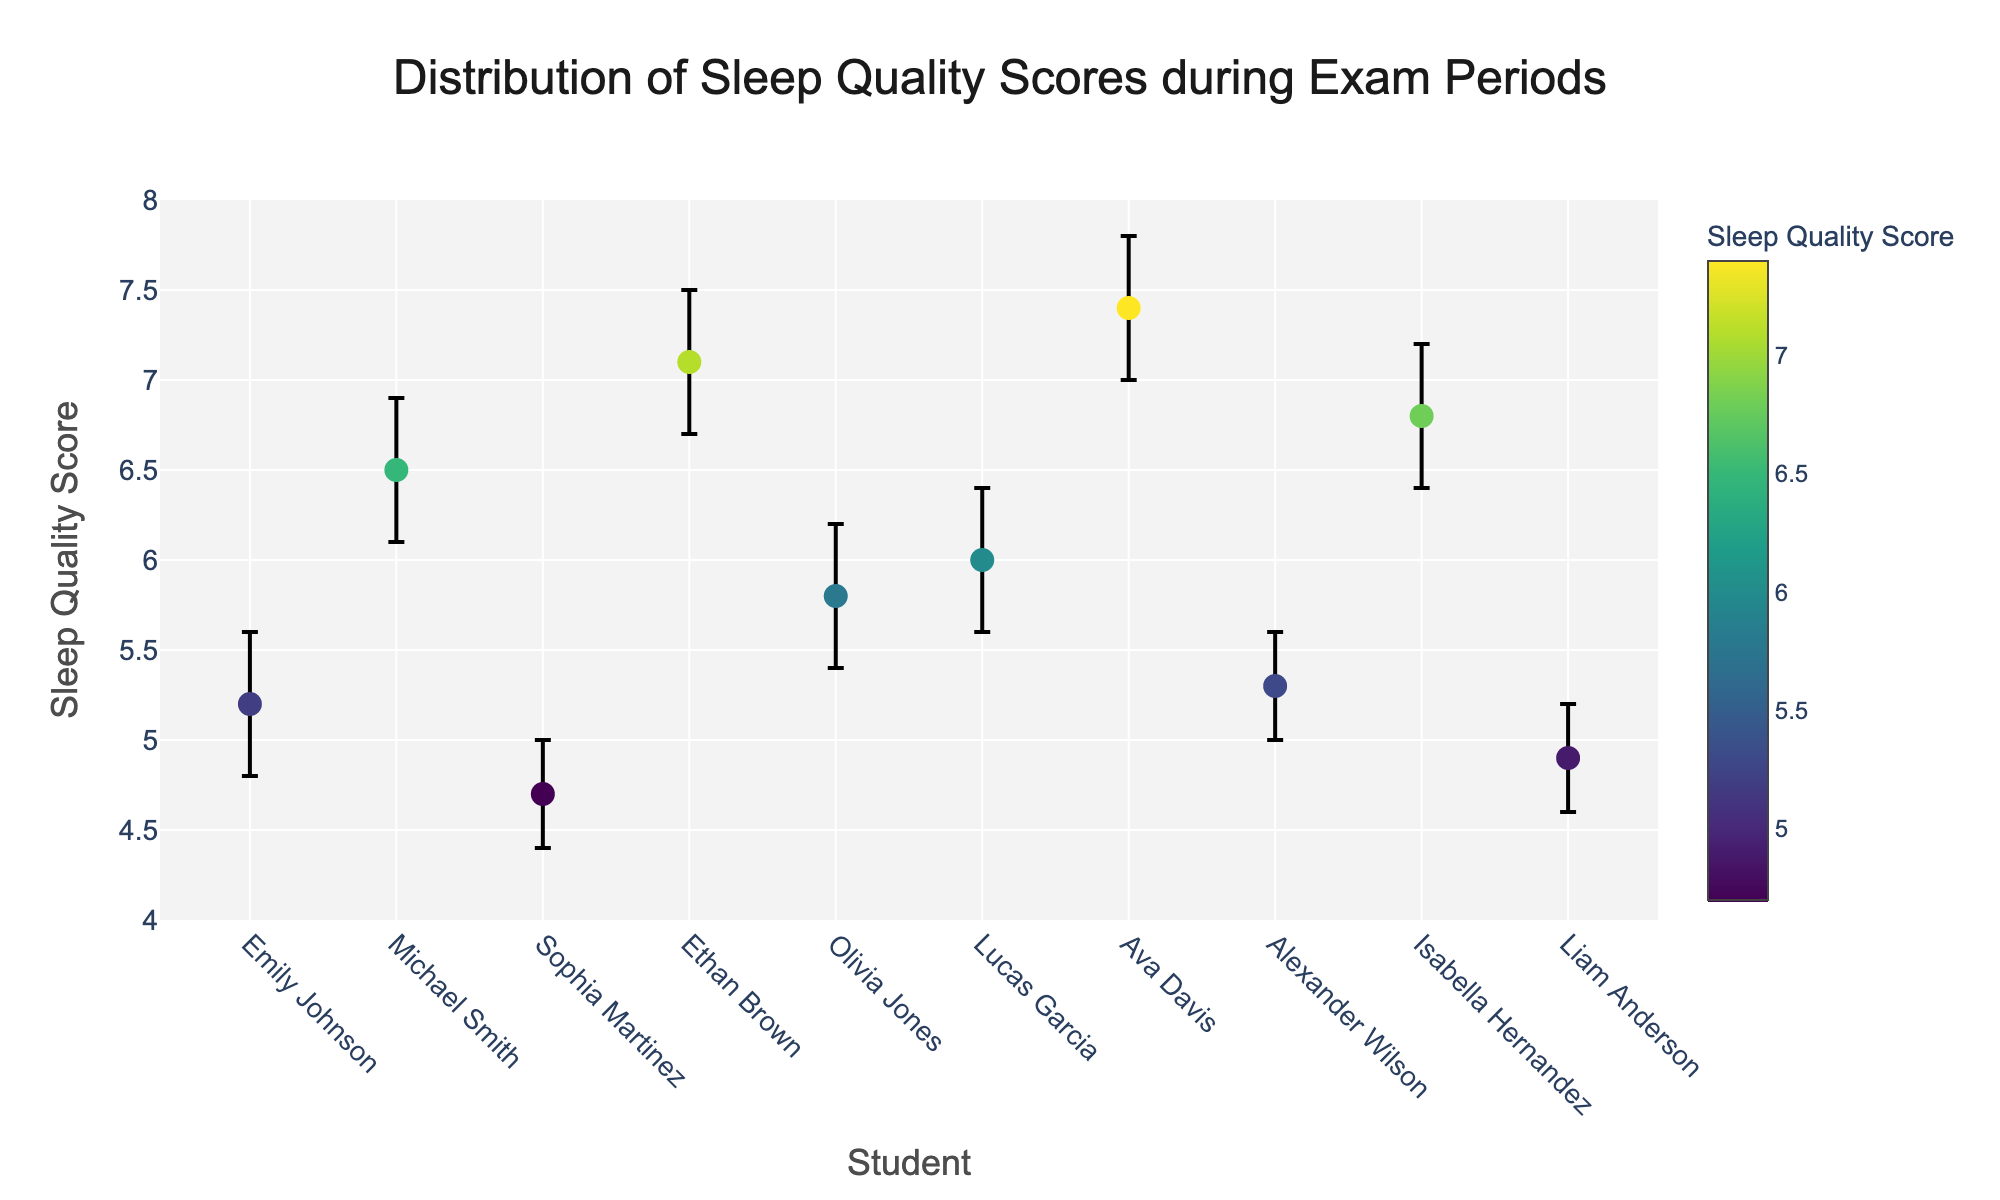What's the title of the figure? The title of the figure is displayed at the top, centered. It reads "Distribution of Sleep Quality Scores during Exam Periods."
Answer: Distribution of Sleep Quality Scores during Exam Periods How many students are represented in the plot? By counting the labels or markers on the x-axis, we can see that there are 10 students represented in the plot. Each marker corresponds to a different student.
Answer: 10 What is the range of sleep quality scores shown on the y-axis? The y-axis in the plot is labeled "Sleep Quality Score" and ranges from 4 to 8, as indicated by the axis labels and the tick marks.
Answer: 4 to 8 Which student has the highest sleep quality score? By examining the markers on the graph, the highest sleep quality score is 7.4, which belongs to Ava Davis as indicated by the label.
Answer: Ava Davis What is the sleep quality score for Michael Smith? The plot shows a marker for Michael Smith with a sleep quality score of 6.5.
Answer: 6.5 For which student is the confidence interval the widest? To determine the widest confidence interval, we compare the length of error bars. Ethan Brown has the widest interval ranging from 6.7 to 7.5.
Answer: Ethan Brown Which student has the lowest sleep quality score? The lowest sleep quality score is represented by Sophia Martinez at 4.7, as indicated by the graph.
Answer: Sophia Martinez What is the difference between the highest and lowest sleep quality scores? The highest score is 7.4 (Ava Davis), and the lowest score is 4.7 (Sophia Martinez). The difference is calculated as 7.4 - 4.7.
Answer: 2.7 Compare the sleep quality score of Emily Johnson and Olivia Jones. Who has a higher score? From the figure, Emily Johnson has a sleep quality score of 5.2, and Olivia Jones has a score of 5.8. Olivia Jones has a higher score.
Answer: Olivia Jones What is the average sleep quality score among the students? The sum of all sleep quality scores is 5.2 + 6.5 + 4.7 + 7.1 + 5.8 + 6.0 + 7.4 + 5.3 + 6.8 + 4.9. This totals to 60.7. Dividing by the number of students (10) gives the average score.
Answer: 6.07 